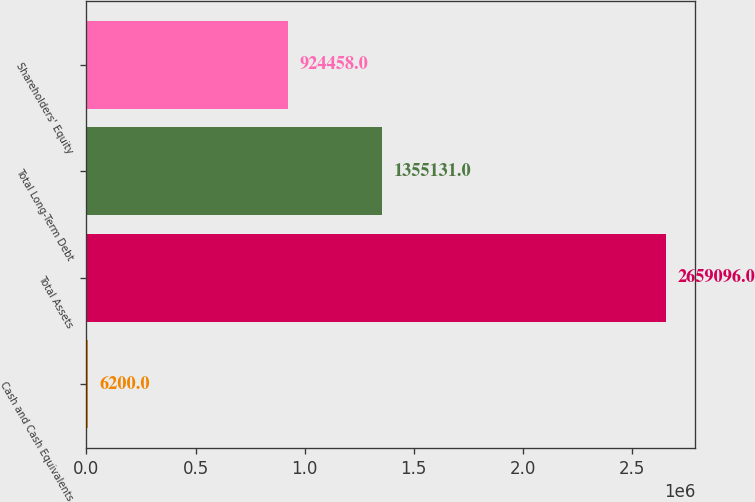Convert chart to OTSL. <chart><loc_0><loc_0><loc_500><loc_500><bar_chart><fcel>Cash and Cash Equivalents<fcel>Total Assets<fcel>Total Long-Term Debt<fcel>Shareholders' Equity<nl><fcel>6200<fcel>2.6591e+06<fcel>1.35513e+06<fcel>924458<nl></chart> 